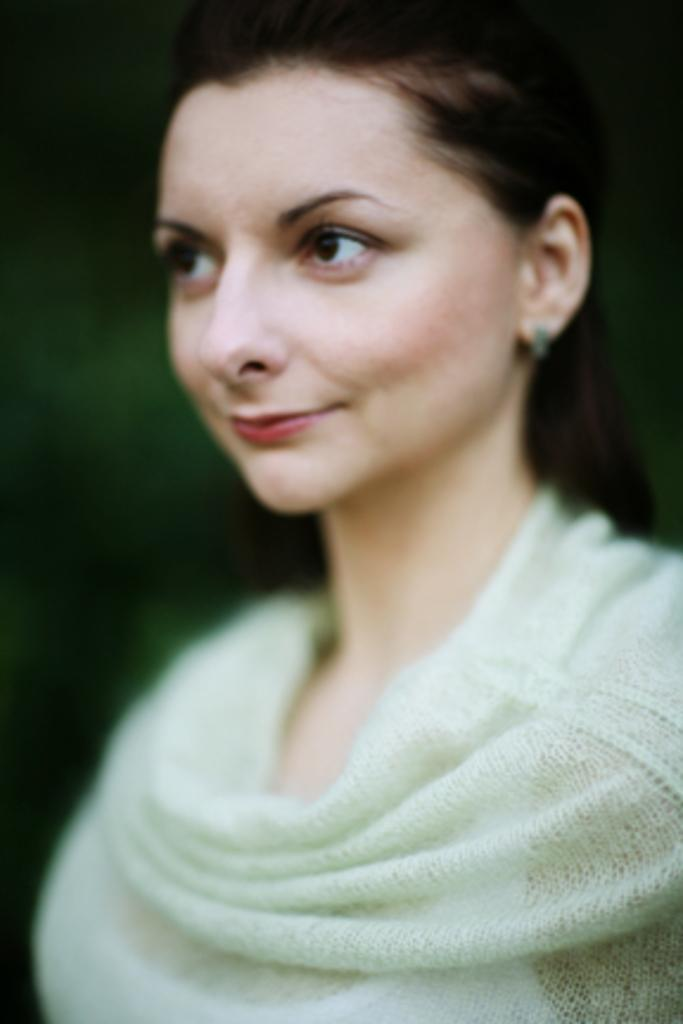What is the main subject of the image? There is a smiling woman in the image. Can you describe the background color in the image? The background color in the image is mentioned as blue in green. What type of structure can be seen in the background of the image? There is no structure visible in the background of the image; only the smiling woman and the mentioned background color are present. What type of underwear is the woman wearing in the image? There is no information about the woman's underwear in the image, as the focus is on her smile and the background color. 